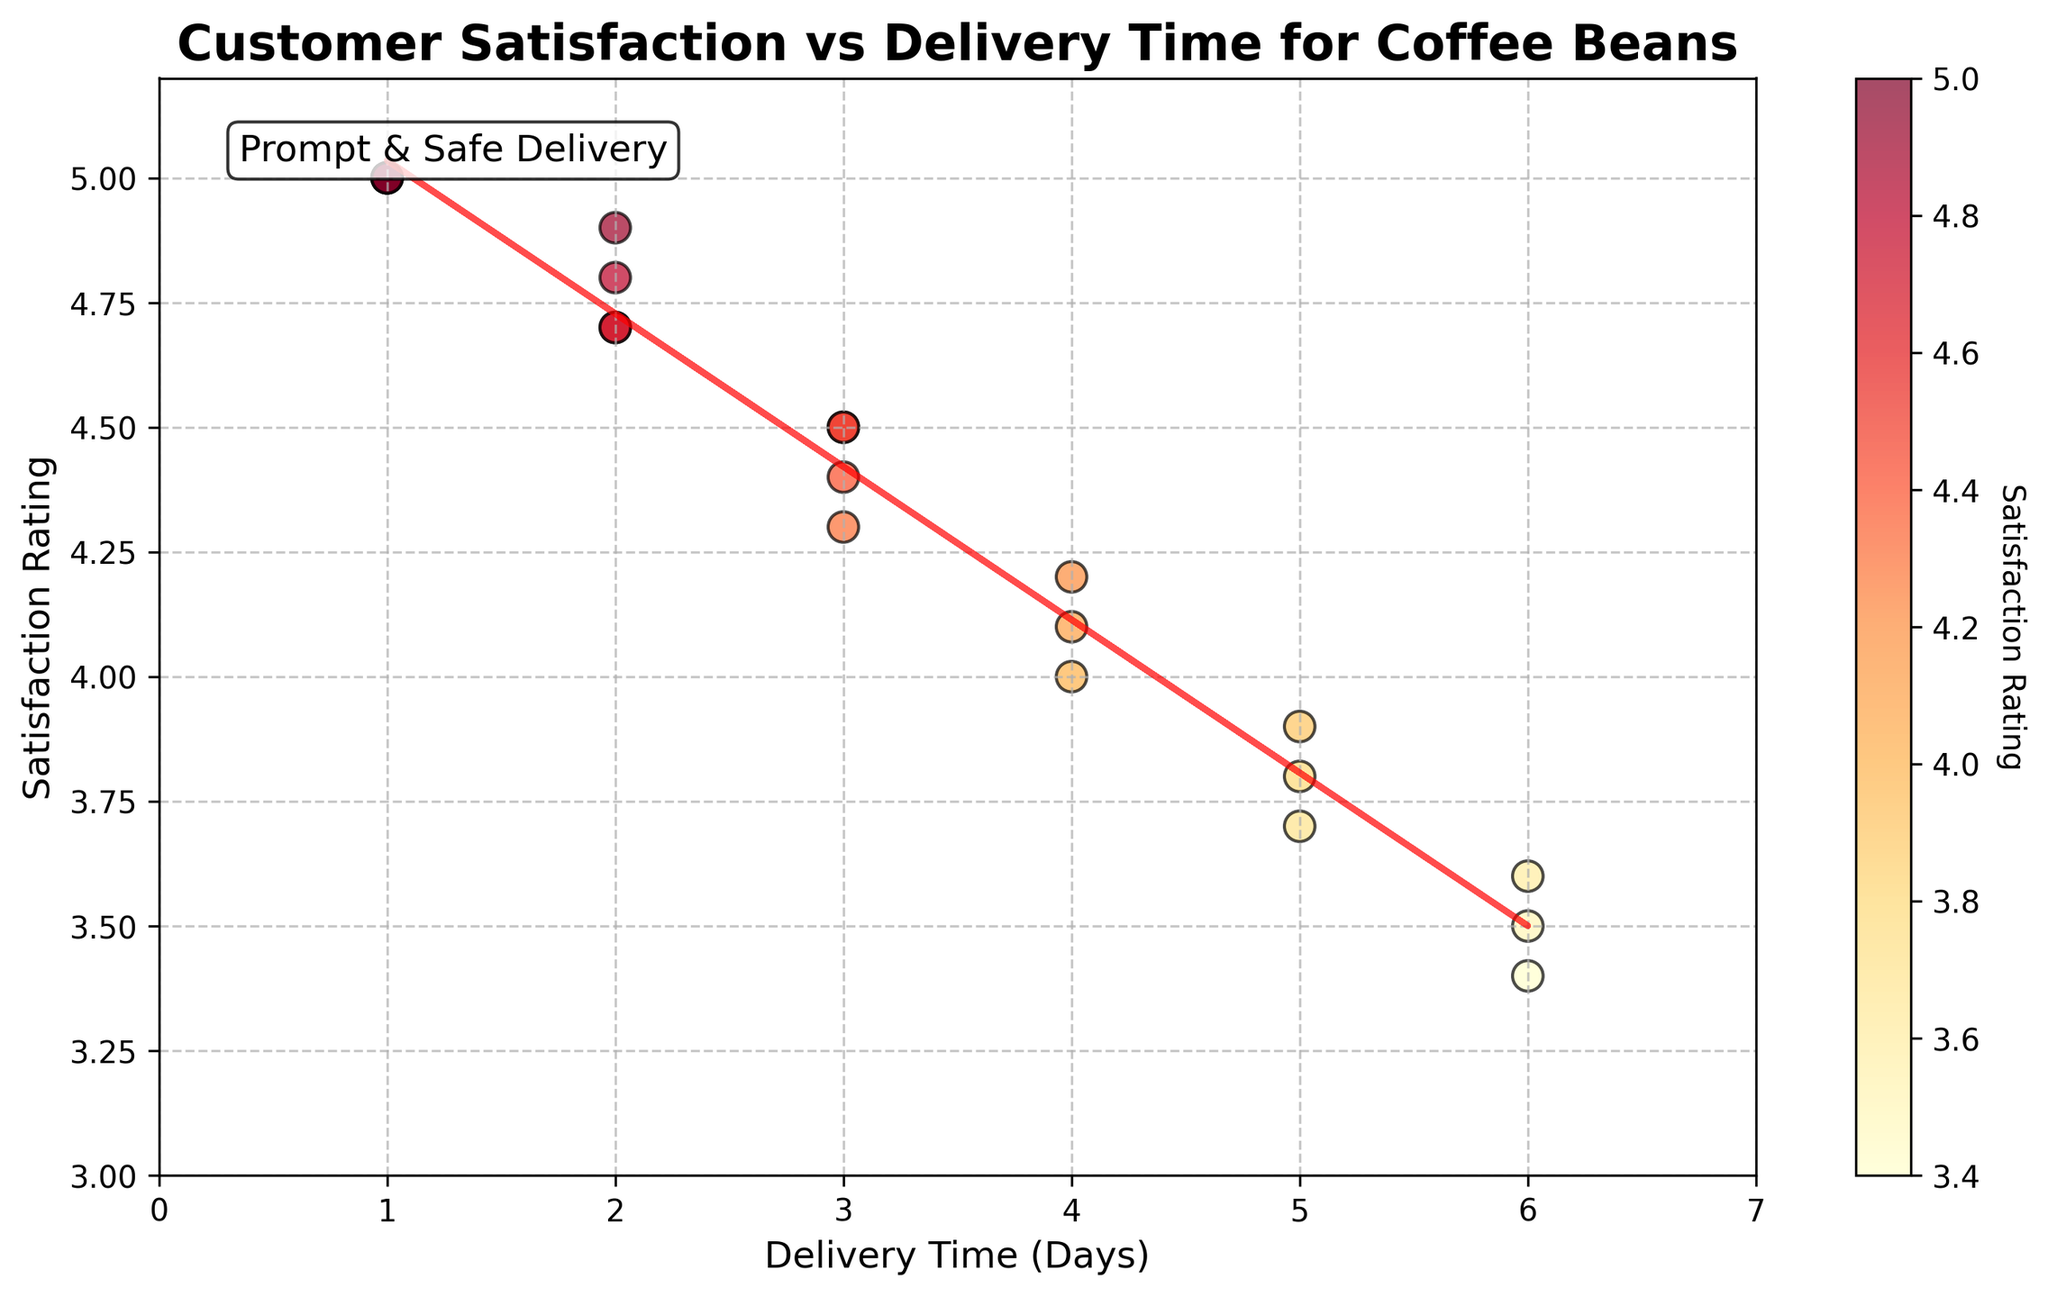What's the title of the plot? The title of a plot is usually found at the top and gives a quick insight into what the chart represents. In this case, the title "Customer Satisfaction vs Delivery Time for Coffee Beans” describes the relationship being explored between delivery time and customer satisfaction ratings.
Answer: Customer Satisfaction vs Delivery Time for Coffee Beans What is the range of the Satisfaction Rating axis? The Satisfaction Rating axis is the vertical axis (y-axis), and it shows values from the minimum to the maximum ratings. By looking at the plotted values, we see that the ratings range from 3 to 5.2.
Answer: 3 to 5.2 How many data points have a delivery time of 2 days? To determine this, count the number of points along the x-axis that are aligned with the value 2. From the data or the plot, we can see there are 4 such points.
Answer: 4 Is there a trend between delivery time and satisfaction rating? By observing the trend line which slopes downwards, it indicates that as the delivery time increases, the satisfaction rating decreases. This downward trend shows an inverse relationship.
Answer: Yes, satisfaction decreases as delivery time increases What delivery time has the highest satisfaction rating on average? To find this, average the satisfaction ratings for each delivery time and identify the one with the highest average. Observing the plot, delivery times of 1 day consistently have the highest satisfaction ratings (all ratings are 5.0).
Answer: 1 day Which customer has the lowest satisfaction rating, and what is their delivery time? Locate the lowest point on the y-axis on the scatter plot, then check the corresponding x-axis value. The lowest satisfaction rating is 3.4, which corresponds to a delivery time of 6 days. According to the data, this is Jack Black.
Answer: Jack Black, 6 days What is the color scheme used for the scatter plot points? The scatter plot points use a gradient color scheme ranging from yellow to red, which corresponds to the satisfaction rating, with yellow indicating higher ratings and red indicating lower. This helps in visually distinguishing between different satisfaction levels.
Answer: Yellow to red Compare the satisfaction ratings for delivery times of 3 days and 6 days. Which is generally higher? Check the satisfaction ratings for data points at 3 days and 6 days on the x-axis. The 3-day points have ratings mostly in the range of 4.3 to 4.5, while the 6-day points are in the range of 3.4 to 3.6. Therefore, the satisfaction ratings are generally higher for 3-day deliveries.
Answer: 3 days What is the purpose of the text annotation "Prompt & Safe Delivery" in the plot? The text annotation typically highlights a key insight or recommendation based on the data. "Prompt & Safe Delivery" emphasizes the importance of ensuring quick deliveries for higher customer satisfaction, as shown by the trend in the plot.
Answer: To emphasize quick deliveries for higher satisfaction How does the delivery time of 5 days affect the trend line compared to 1 day? On observing the trend line behavior and data points, 5-day deliveries have noticeably lower satisfaction ratings (around 3.7 to 3.9) compared to 1-day deliveries which consistently have the highest ratings (5.0). These lower ratings at higher delivery times pull the trend line downwards, indicating a negative impact.
Answer: Negatively, as it lowers the trend line compared to 1 day 